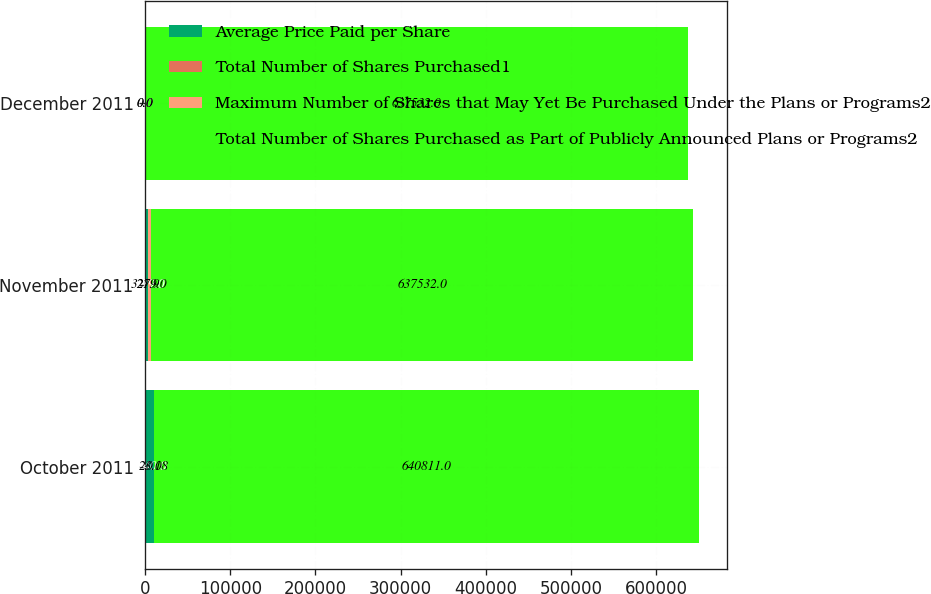Convert chart. <chart><loc_0><loc_0><loc_500><loc_500><stacked_bar_chart><ecel><fcel>October 2011<fcel>November 2011<fcel>December 2011<nl><fcel>Average Price Paid per Share<fcel>9740<fcel>3279<fcel>0<nl><fcel>Total Number of Shares Purchased1<fcel>23.18<fcel>21.9<fcel>0<nl><fcel>Maximum Number of Shares that May Yet Be Purchased Under the Plans or Programs2<fcel>0<fcel>3279<fcel>0<nl><fcel>Total Number of Shares Purchased as Part of Publicly Announced Plans or Programs2<fcel>640811<fcel>637532<fcel>637532<nl></chart> 